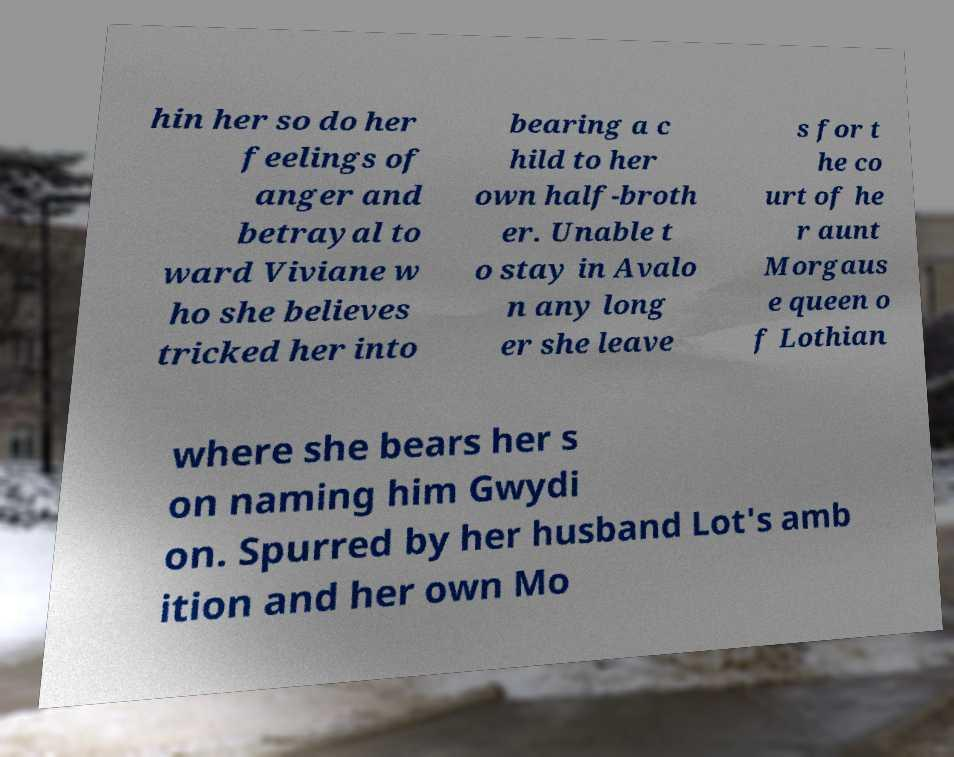What messages or text are displayed in this image? I need them in a readable, typed format. hin her so do her feelings of anger and betrayal to ward Viviane w ho she believes tricked her into bearing a c hild to her own half-broth er. Unable t o stay in Avalo n any long er she leave s for t he co urt of he r aunt Morgaus e queen o f Lothian where she bears her s on naming him Gwydi on. Spurred by her husband Lot's amb ition and her own Mo 